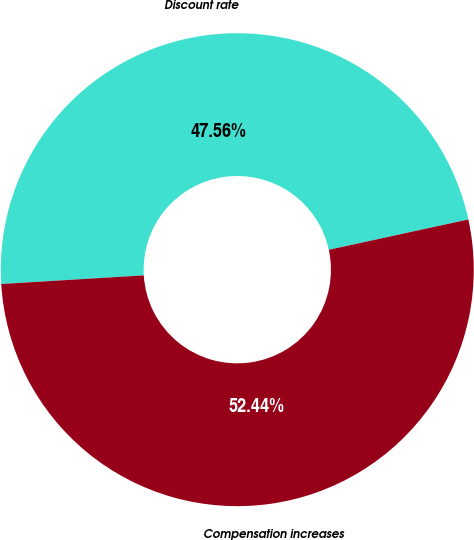Convert chart to OTSL. <chart><loc_0><loc_0><loc_500><loc_500><pie_chart><fcel>Discount rate<fcel>Compensation increases<nl><fcel>47.56%<fcel>52.44%<nl></chart> 